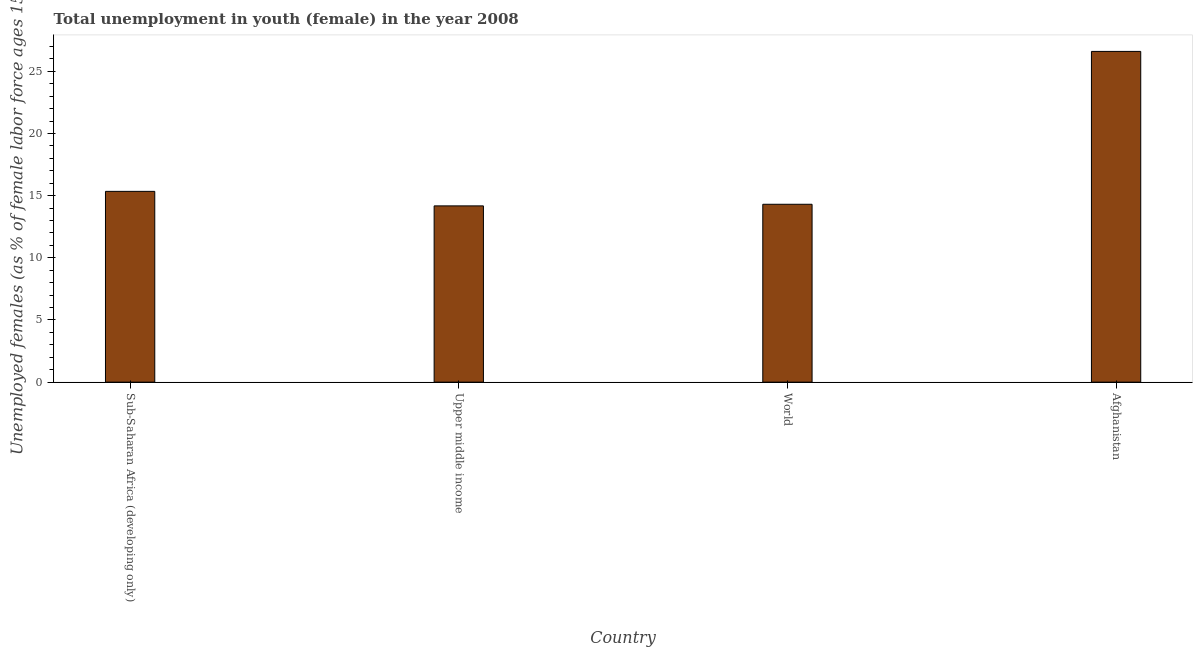Does the graph contain any zero values?
Your response must be concise. No. Does the graph contain grids?
Keep it short and to the point. No. What is the title of the graph?
Offer a terse response. Total unemployment in youth (female) in the year 2008. What is the label or title of the X-axis?
Make the answer very short. Country. What is the label or title of the Y-axis?
Offer a terse response. Unemployed females (as % of female labor force ages 15-24). What is the unemployed female youth population in World?
Your response must be concise. 14.31. Across all countries, what is the maximum unemployed female youth population?
Provide a short and direct response. 26.6. Across all countries, what is the minimum unemployed female youth population?
Your answer should be compact. 14.18. In which country was the unemployed female youth population maximum?
Your answer should be compact. Afghanistan. In which country was the unemployed female youth population minimum?
Offer a terse response. Upper middle income. What is the sum of the unemployed female youth population?
Your answer should be compact. 70.43. What is the difference between the unemployed female youth population in Afghanistan and Upper middle income?
Provide a succinct answer. 12.42. What is the average unemployed female youth population per country?
Your answer should be very brief. 17.61. What is the median unemployed female youth population?
Provide a short and direct response. 14.82. What is the ratio of the unemployed female youth population in Upper middle income to that in World?
Keep it short and to the point. 0.99. Is the difference between the unemployed female youth population in Afghanistan and Sub-Saharan Africa (developing only) greater than the difference between any two countries?
Offer a terse response. No. What is the difference between the highest and the second highest unemployed female youth population?
Offer a very short reply. 11.26. Is the sum of the unemployed female youth population in Sub-Saharan Africa (developing only) and World greater than the maximum unemployed female youth population across all countries?
Provide a succinct answer. Yes. What is the difference between the highest and the lowest unemployed female youth population?
Offer a terse response. 12.42. In how many countries, is the unemployed female youth population greater than the average unemployed female youth population taken over all countries?
Offer a very short reply. 1. How many bars are there?
Ensure brevity in your answer.  4. How many countries are there in the graph?
Your answer should be compact. 4. What is the Unemployed females (as % of female labor force ages 15-24) of Sub-Saharan Africa (developing only)?
Offer a terse response. 15.34. What is the Unemployed females (as % of female labor force ages 15-24) in Upper middle income?
Provide a short and direct response. 14.18. What is the Unemployed females (as % of female labor force ages 15-24) of World?
Keep it short and to the point. 14.31. What is the Unemployed females (as % of female labor force ages 15-24) in Afghanistan?
Offer a very short reply. 26.6. What is the difference between the Unemployed females (as % of female labor force ages 15-24) in Sub-Saharan Africa (developing only) and Upper middle income?
Ensure brevity in your answer.  1.17. What is the difference between the Unemployed females (as % of female labor force ages 15-24) in Sub-Saharan Africa (developing only) and World?
Keep it short and to the point. 1.04. What is the difference between the Unemployed females (as % of female labor force ages 15-24) in Sub-Saharan Africa (developing only) and Afghanistan?
Provide a short and direct response. -11.26. What is the difference between the Unemployed females (as % of female labor force ages 15-24) in Upper middle income and World?
Offer a very short reply. -0.13. What is the difference between the Unemployed females (as % of female labor force ages 15-24) in Upper middle income and Afghanistan?
Make the answer very short. -12.42. What is the difference between the Unemployed females (as % of female labor force ages 15-24) in World and Afghanistan?
Offer a very short reply. -12.29. What is the ratio of the Unemployed females (as % of female labor force ages 15-24) in Sub-Saharan Africa (developing only) to that in Upper middle income?
Ensure brevity in your answer.  1.08. What is the ratio of the Unemployed females (as % of female labor force ages 15-24) in Sub-Saharan Africa (developing only) to that in World?
Your response must be concise. 1.07. What is the ratio of the Unemployed females (as % of female labor force ages 15-24) in Sub-Saharan Africa (developing only) to that in Afghanistan?
Your answer should be very brief. 0.58. What is the ratio of the Unemployed females (as % of female labor force ages 15-24) in Upper middle income to that in World?
Ensure brevity in your answer.  0.99. What is the ratio of the Unemployed females (as % of female labor force ages 15-24) in Upper middle income to that in Afghanistan?
Provide a short and direct response. 0.53. What is the ratio of the Unemployed females (as % of female labor force ages 15-24) in World to that in Afghanistan?
Offer a very short reply. 0.54. 